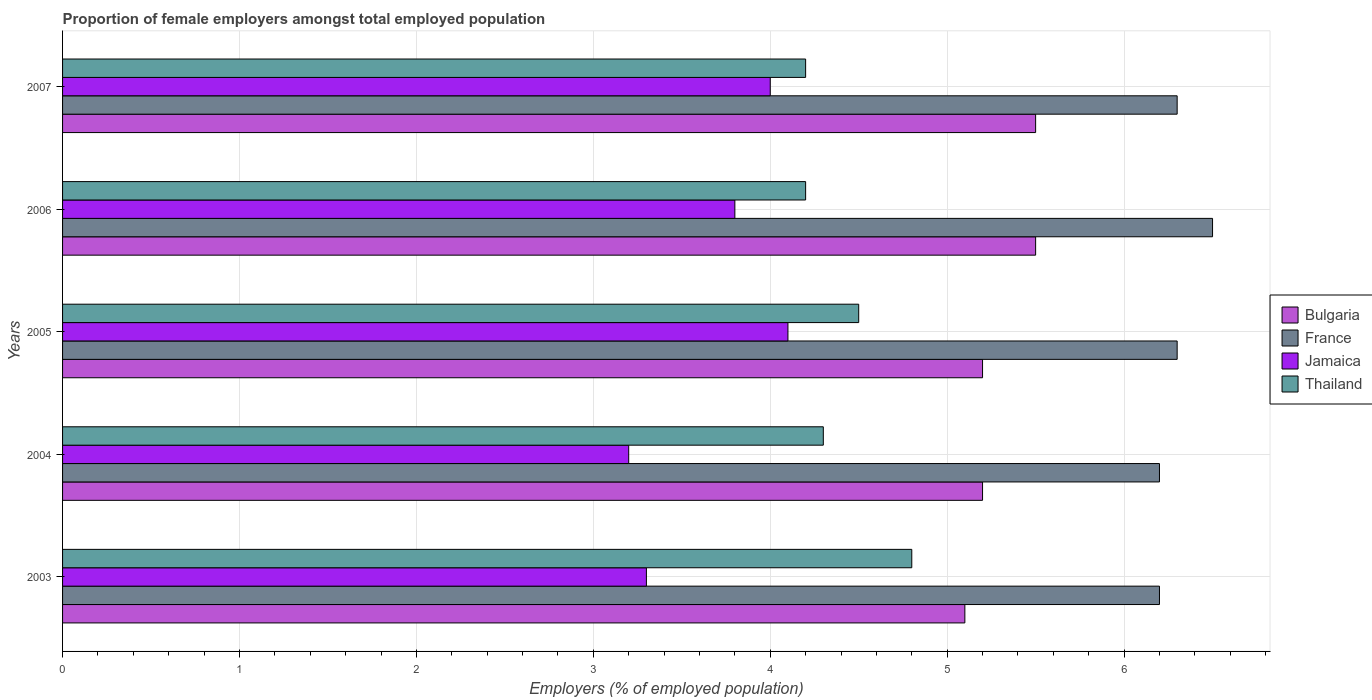Are the number of bars per tick equal to the number of legend labels?
Your answer should be compact. Yes. What is the label of the 3rd group of bars from the top?
Keep it short and to the point. 2005. In how many cases, is the number of bars for a given year not equal to the number of legend labels?
Make the answer very short. 0. What is the proportion of female employers in Jamaica in 2004?
Give a very brief answer. 3.2. Across all years, what is the maximum proportion of female employers in Jamaica?
Ensure brevity in your answer.  4.1. Across all years, what is the minimum proportion of female employers in Bulgaria?
Your response must be concise. 5.1. In which year was the proportion of female employers in Jamaica maximum?
Provide a short and direct response. 2005. What is the total proportion of female employers in Jamaica in the graph?
Your answer should be very brief. 18.4. What is the difference between the proportion of female employers in Thailand in 2004 and that in 2007?
Provide a short and direct response. 0.1. What is the difference between the proportion of female employers in Thailand in 2004 and the proportion of female employers in France in 2003?
Your answer should be very brief. -1.9. What is the average proportion of female employers in Bulgaria per year?
Offer a terse response. 5.3. In the year 2005, what is the difference between the proportion of female employers in Bulgaria and proportion of female employers in Jamaica?
Provide a succinct answer. 1.1. What is the ratio of the proportion of female employers in Thailand in 2003 to that in 2004?
Provide a succinct answer. 1.12. Is the proportion of female employers in Jamaica in 2003 less than that in 2004?
Ensure brevity in your answer.  No. Is the difference between the proportion of female employers in Bulgaria in 2003 and 2005 greater than the difference between the proportion of female employers in Jamaica in 2003 and 2005?
Offer a terse response. Yes. What is the difference between the highest and the second highest proportion of female employers in France?
Offer a very short reply. 0.2. What is the difference between the highest and the lowest proportion of female employers in Bulgaria?
Your response must be concise. 0.4. Is it the case that in every year, the sum of the proportion of female employers in Jamaica and proportion of female employers in Bulgaria is greater than the sum of proportion of female employers in Thailand and proportion of female employers in France?
Provide a succinct answer. Yes. What does the 4th bar from the top in 2004 represents?
Provide a short and direct response. Bulgaria. What is the difference between two consecutive major ticks on the X-axis?
Your answer should be compact. 1. Does the graph contain any zero values?
Offer a terse response. No. Does the graph contain grids?
Give a very brief answer. Yes. Where does the legend appear in the graph?
Provide a succinct answer. Center right. How many legend labels are there?
Your answer should be very brief. 4. What is the title of the graph?
Your answer should be compact. Proportion of female employers amongst total employed population. Does "Somalia" appear as one of the legend labels in the graph?
Your answer should be compact. No. What is the label or title of the X-axis?
Offer a terse response. Employers (% of employed population). What is the Employers (% of employed population) in Bulgaria in 2003?
Offer a terse response. 5.1. What is the Employers (% of employed population) in France in 2003?
Make the answer very short. 6.2. What is the Employers (% of employed population) of Jamaica in 2003?
Give a very brief answer. 3.3. What is the Employers (% of employed population) of Thailand in 2003?
Provide a short and direct response. 4.8. What is the Employers (% of employed population) of Bulgaria in 2004?
Give a very brief answer. 5.2. What is the Employers (% of employed population) in France in 2004?
Provide a short and direct response. 6.2. What is the Employers (% of employed population) of Jamaica in 2004?
Ensure brevity in your answer.  3.2. What is the Employers (% of employed population) in Thailand in 2004?
Ensure brevity in your answer.  4.3. What is the Employers (% of employed population) of Bulgaria in 2005?
Give a very brief answer. 5.2. What is the Employers (% of employed population) of France in 2005?
Keep it short and to the point. 6.3. What is the Employers (% of employed population) in Jamaica in 2005?
Offer a terse response. 4.1. What is the Employers (% of employed population) in Thailand in 2005?
Give a very brief answer. 4.5. What is the Employers (% of employed population) of Bulgaria in 2006?
Provide a short and direct response. 5.5. What is the Employers (% of employed population) in France in 2006?
Provide a short and direct response. 6.5. What is the Employers (% of employed population) in Jamaica in 2006?
Make the answer very short. 3.8. What is the Employers (% of employed population) in Thailand in 2006?
Ensure brevity in your answer.  4.2. What is the Employers (% of employed population) of France in 2007?
Your answer should be compact. 6.3. What is the Employers (% of employed population) of Jamaica in 2007?
Your answer should be very brief. 4. What is the Employers (% of employed population) of Thailand in 2007?
Ensure brevity in your answer.  4.2. Across all years, what is the maximum Employers (% of employed population) of Bulgaria?
Provide a succinct answer. 5.5. Across all years, what is the maximum Employers (% of employed population) in France?
Offer a very short reply. 6.5. Across all years, what is the maximum Employers (% of employed population) in Jamaica?
Your response must be concise. 4.1. Across all years, what is the maximum Employers (% of employed population) of Thailand?
Give a very brief answer. 4.8. Across all years, what is the minimum Employers (% of employed population) of Bulgaria?
Ensure brevity in your answer.  5.1. Across all years, what is the minimum Employers (% of employed population) in France?
Your answer should be compact. 6.2. Across all years, what is the minimum Employers (% of employed population) in Jamaica?
Offer a very short reply. 3.2. Across all years, what is the minimum Employers (% of employed population) in Thailand?
Give a very brief answer. 4.2. What is the total Employers (% of employed population) in France in the graph?
Give a very brief answer. 31.5. What is the total Employers (% of employed population) in Jamaica in the graph?
Your answer should be very brief. 18.4. What is the total Employers (% of employed population) in Thailand in the graph?
Provide a short and direct response. 22. What is the difference between the Employers (% of employed population) in France in 2003 and that in 2004?
Give a very brief answer. 0. What is the difference between the Employers (% of employed population) in Jamaica in 2003 and that in 2004?
Offer a terse response. 0.1. What is the difference between the Employers (% of employed population) in Thailand in 2003 and that in 2004?
Offer a very short reply. 0.5. What is the difference between the Employers (% of employed population) in Jamaica in 2003 and that in 2005?
Keep it short and to the point. -0.8. What is the difference between the Employers (% of employed population) in Bulgaria in 2003 and that in 2006?
Give a very brief answer. -0.4. What is the difference between the Employers (% of employed population) in France in 2003 and that in 2006?
Provide a succinct answer. -0.3. What is the difference between the Employers (% of employed population) of France in 2003 and that in 2007?
Provide a short and direct response. -0.1. What is the difference between the Employers (% of employed population) in Jamaica in 2003 and that in 2007?
Provide a succinct answer. -0.7. What is the difference between the Employers (% of employed population) in Thailand in 2003 and that in 2007?
Offer a very short reply. 0.6. What is the difference between the Employers (% of employed population) of Jamaica in 2004 and that in 2005?
Ensure brevity in your answer.  -0.9. What is the difference between the Employers (% of employed population) of Thailand in 2004 and that in 2005?
Provide a succinct answer. -0.2. What is the difference between the Employers (% of employed population) in Bulgaria in 2004 and that in 2006?
Your answer should be compact. -0.3. What is the difference between the Employers (% of employed population) of Thailand in 2004 and that in 2006?
Provide a succinct answer. 0.1. What is the difference between the Employers (% of employed population) of Thailand in 2004 and that in 2007?
Offer a very short reply. 0.1. What is the difference between the Employers (% of employed population) in Bulgaria in 2005 and that in 2007?
Provide a succinct answer. -0.3. What is the difference between the Employers (% of employed population) in Jamaica in 2005 and that in 2007?
Your response must be concise. 0.1. What is the difference between the Employers (% of employed population) in Thailand in 2005 and that in 2007?
Provide a succinct answer. 0.3. What is the difference between the Employers (% of employed population) of Bulgaria in 2003 and the Employers (% of employed population) of France in 2004?
Provide a short and direct response. -1.1. What is the difference between the Employers (% of employed population) of Bulgaria in 2003 and the Employers (% of employed population) of Jamaica in 2004?
Offer a terse response. 1.9. What is the difference between the Employers (% of employed population) in Bulgaria in 2003 and the Employers (% of employed population) in France in 2005?
Offer a very short reply. -1.2. What is the difference between the Employers (% of employed population) in Bulgaria in 2003 and the Employers (% of employed population) in Thailand in 2005?
Offer a very short reply. 0.6. What is the difference between the Employers (% of employed population) in France in 2003 and the Employers (% of employed population) in Jamaica in 2005?
Provide a succinct answer. 2.1. What is the difference between the Employers (% of employed population) in Bulgaria in 2003 and the Employers (% of employed population) in France in 2006?
Offer a terse response. -1.4. What is the difference between the Employers (% of employed population) of Bulgaria in 2003 and the Employers (% of employed population) of Jamaica in 2006?
Offer a terse response. 1.3. What is the difference between the Employers (% of employed population) of Bulgaria in 2003 and the Employers (% of employed population) of Thailand in 2006?
Ensure brevity in your answer.  0.9. What is the difference between the Employers (% of employed population) of France in 2003 and the Employers (% of employed population) of Jamaica in 2006?
Provide a succinct answer. 2.4. What is the difference between the Employers (% of employed population) in France in 2003 and the Employers (% of employed population) in Thailand in 2006?
Give a very brief answer. 2. What is the difference between the Employers (% of employed population) of Jamaica in 2003 and the Employers (% of employed population) of Thailand in 2006?
Give a very brief answer. -0.9. What is the difference between the Employers (% of employed population) in Bulgaria in 2003 and the Employers (% of employed population) in Jamaica in 2007?
Provide a succinct answer. 1.1. What is the difference between the Employers (% of employed population) in Bulgaria in 2003 and the Employers (% of employed population) in Thailand in 2007?
Keep it short and to the point. 0.9. What is the difference between the Employers (% of employed population) of France in 2003 and the Employers (% of employed population) of Jamaica in 2007?
Provide a short and direct response. 2.2. What is the difference between the Employers (% of employed population) of Bulgaria in 2004 and the Employers (% of employed population) of France in 2005?
Your answer should be very brief. -1.1. What is the difference between the Employers (% of employed population) of Bulgaria in 2004 and the Employers (% of employed population) of Jamaica in 2005?
Keep it short and to the point. 1.1. What is the difference between the Employers (% of employed population) of Bulgaria in 2004 and the Employers (% of employed population) of Thailand in 2005?
Keep it short and to the point. 0.7. What is the difference between the Employers (% of employed population) of France in 2004 and the Employers (% of employed population) of Jamaica in 2005?
Keep it short and to the point. 2.1. What is the difference between the Employers (% of employed population) of Bulgaria in 2004 and the Employers (% of employed population) of Thailand in 2006?
Your response must be concise. 1. What is the difference between the Employers (% of employed population) in France in 2004 and the Employers (% of employed population) in Jamaica in 2006?
Offer a terse response. 2.4. What is the difference between the Employers (% of employed population) of Bulgaria in 2004 and the Employers (% of employed population) of Jamaica in 2007?
Your answer should be very brief. 1.2. What is the difference between the Employers (% of employed population) in Bulgaria in 2005 and the Employers (% of employed population) in Jamaica in 2006?
Make the answer very short. 1.4. What is the difference between the Employers (% of employed population) in Bulgaria in 2005 and the Employers (% of employed population) in Thailand in 2006?
Your response must be concise. 1. What is the difference between the Employers (% of employed population) in France in 2005 and the Employers (% of employed population) in Jamaica in 2006?
Make the answer very short. 2.5. What is the difference between the Employers (% of employed population) of France in 2005 and the Employers (% of employed population) of Thailand in 2006?
Your answer should be compact. 2.1. What is the difference between the Employers (% of employed population) of Jamaica in 2005 and the Employers (% of employed population) of Thailand in 2006?
Offer a very short reply. -0.1. What is the difference between the Employers (% of employed population) in Bulgaria in 2005 and the Employers (% of employed population) in France in 2007?
Provide a short and direct response. -1.1. What is the difference between the Employers (% of employed population) in Bulgaria in 2005 and the Employers (% of employed population) in Jamaica in 2007?
Provide a succinct answer. 1.2. What is the difference between the Employers (% of employed population) in Bulgaria in 2006 and the Employers (% of employed population) in Jamaica in 2007?
Your response must be concise. 1.5. What is the difference between the Employers (% of employed population) of Bulgaria in 2006 and the Employers (% of employed population) of Thailand in 2007?
Provide a succinct answer. 1.3. What is the difference between the Employers (% of employed population) of France in 2006 and the Employers (% of employed population) of Thailand in 2007?
Make the answer very short. 2.3. What is the difference between the Employers (% of employed population) of Jamaica in 2006 and the Employers (% of employed population) of Thailand in 2007?
Offer a terse response. -0.4. What is the average Employers (% of employed population) in Bulgaria per year?
Ensure brevity in your answer.  5.3. What is the average Employers (% of employed population) of France per year?
Provide a short and direct response. 6.3. What is the average Employers (% of employed population) in Jamaica per year?
Keep it short and to the point. 3.68. What is the average Employers (% of employed population) in Thailand per year?
Offer a terse response. 4.4. In the year 2003, what is the difference between the Employers (% of employed population) of Bulgaria and Employers (% of employed population) of Jamaica?
Your answer should be very brief. 1.8. In the year 2003, what is the difference between the Employers (% of employed population) in France and Employers (% of employed population) in Jamaica?
Ensure brevity in your answer.  2.9. In the year 2003, what is the difference between the Employers (% of employed population) in Jamaica and Employers (% of employed population) in Thailand?
Your answer should be very brief. -1.5. In the year 2004, what is the difference between the Employers (% of employed population) of Bulgaria and Employers (% of employed population) of France?
Give a very brief answer. -1. In the year 2004, what is the difference between the Employers (% of employed population) in Bulgaria and Employers (% of employed population) in Jamaica?
Ensure brevity in your answer.  2. In the year 2004, what is the difference between the Employers (% of employed population) in France and Employers (% of employed population) in Thailand?
Keep it short and to the point. 1.9. In the year 2004, what is the difference between the Employers (% of employed population) of Jamaica and Employers (% of employed population) of Thailand?
Your response must be concise. -1.1. In the year 2005, what is the difference between the Employers (% of employed population) of Bulgaria and Employers (% of employed population) of Jamaica?
Give a very brief answer. 1.1. In the year 2005, what is the difference between the Employers (% of employed population) of Bulgaria and Employers (% of employed population) of Thailand?
Provide a succinct answer. 0.7. In the year 2005, what is the difference between the Employers (% of employed population) of France and Employers (% of employed population) of Jamaica?
Your answer should be very brief. 2.2. In the year 2005, what is the difference between the Employers (% of employed population) of Jamaica and Employers (% of employed population) of Thailand?
Your answer should be compact. -0.4. In the year 2006, what is the difference between the Employers (% of employed population) of Bulgaria and Employers (% of employed population) of Thailand?
Your answer should be compact. 1.3. In the year 2007, what is the difference between the Employers (% of employed population) of Bulgaria and Employers (% of employed population) of Thailand?
Ensure brevity in your answer.  1.3. In the year 2007, what is the difference between the Employers (% of employed population) in Jamaica and Employers (% of employed population) in Thailand?
Your response must be concise. -0.2. What is the ratio of the Employers (% of employed population) in Bulgaria in 2003 to that in 2004?
Offer a terse response. 0.98. What is the ratio of the Employers (% of employed population) of France in 2003 to that in 2004?
Offer a terse response. 1. What is the ratio of the Employers (% of employed population) of Jamaica in 2003 to that in 2004?
Make the answer very short. 1.03. What is the ratio of the Employers (% of employed population) of Thailand in 2003 to that in 2004?
Offer a very short reply. 1.12. What is the ratio of the Employers (% of employed population) of Bulgaria in 2003 to that in 2005?
Your response must be concise. 0.98. What is the ratio of the Employers (% of employed population) in France in 2003 to that in 2005?
Your answer should be compact. 0.98. What is the ratio of the Employers (% of employed population) of Jamaica in 2003 to that in 2005?
Provide a succinct answer. 0.8. What is the ratio of the Employers (% of employed population) of Thailand in 2003 to that in 2005?
Give a very brief answer. 1.07. What is the ratio of the Employers (% of employed population) of Bulgaria in 2003 to that in 2006?
Ensure brevity in your answer.  0.93. What is the ratio of the Employers (% of employed population) of France in 2003 to that in 2006?
Make the answer very short. 0.95. What is the ratio of the Employers (% of employed population) in Jamaica in 2003 to that in 2006?
Provide a succinct answer. 0.87. What is the ratio of the Employers (% of employed population) of Thailand in 2003 to that in 2006?
Make the answer very short. 1.14. What is the ratio of the Employers (% of employed population) in Bulgaria in 2003 to that in 2007?
Give a very brief answer. 0.93. What is the ratio of the Employers (% of employed population) of France in 2003 to that in 2007?
Give a very brief answer. 0.98. What is the ratio of the Employers (% of employed population) in Jamaica in 2003 to that in 2007?
Your answer should be compact. 0.82. What is the ratio of the Employers (% of employed population) in Thailand in 2003 to that in 2007?
Give a very brief answer. 1.14. What is the ratio of the Employers (% of employed population) in France in 2004 to that in 2005?
Keep it short and to the point. 0.98. What is the ratio of the Employers (% of employed population) of Jamaica in 2004 to that in 2005?
Give a very brief answer. 0.78. What is the ratio of the Employers (% of employed population) of Thailand in 2004 to that in 2005?
Keep it short and to the point. 0.96. What is the ratio of the Employers (% of employed population) in Bulgaria in 2004 to that in 2006?
Your answer should be very brief. 0.95. What is the ratio of the Employers (% of employed population) of France in 2004 to that in 2006?
Provide a succinct answer. 0.95. What is the ratio of the Employers (% of employed population) of Jamaica in 2004 to that in 2006?
Offer a very short reply. 0.84. What is the ratio of the Employers (% of employed population) in Thailand in 2004 to that in 2006?
Make the answer very short. 1.02. What is the ratio of the Employers (% of employed population) in Bulgaria in 2004 to that in 2007?
Your answer should be compact. 0.95. What is the ratio of the Employers (% of employed population) of France in 2004 to that in 2007?
Provide a succinct answer. 0.98. What is the ratio of the Employers (% of employed population) of Jamaica in 2004 to that in 2007?
Your response must be concise. 0.8. What is the ratio of the Employers (% of employed population) in Thailand in 2004 to that in 2007?
Keep it short and to the point. 1.02. What is the ratio of the Employers (% of employed population) of Bulgaria in 2005 to that in 2006?
Offer a terse response. 0.95. What is the ratio of the Employers (% of employed population) in France in 2005 to that in 2006?
Your answer should be compact. 0.97. What is the ratio of the Employers (% of employed population) of Jamaica in 2005 to that in 2006?
Your answer should be compact. 1.08. What is the ratio of the Employers (% of employed population) of Thailand in 2005 to that in 2006?
Make the answer very short. 1.07. What is the ratio of the Employers (% of employed population) of Bulgaria in 2005 to that in 2007?
Your answer should be compact. 0.95. What is the ratio of the Employers (% of employed population) in Thailand in 2005 to that in 2007?
Ensure brevity in your answer.  1.07. What is the ratio of the Employers (% of employed population) of France in 2006 to that in 2007?
Your answer should be very brief. 1.03. What is the ratio of the Employers (% of employed population) in Jamaica in 2006 to that in 2007?
Your response must be concise. 0.95. What is the difference between the highest and the second highest Employers (% of employed population) of France?
Offer a terse response. 0.2. What is the difference between the highest and the second highest Employers (% of employed population) in Thailand?
Make the answer very short. 0.3. What is the difference between the highest and the lowest Employers (% of employed population) of Bulgaria?
Make the answer very short. 0.4. 